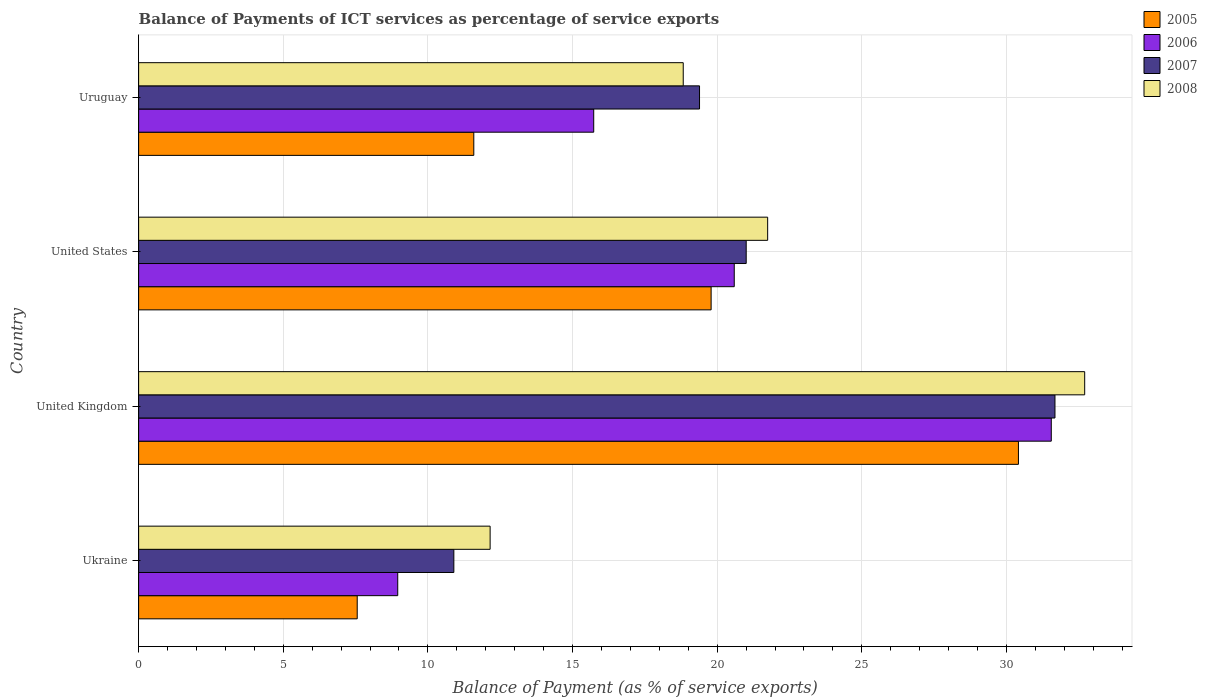How many different coloured bars are there?
Offer a terse response. 4. How many groups of bars are there?
Your answer should be very brief. 4. What is the label of the 2nd group of bars from the top?
Provide a succinct answer. United States. In how many cases, is the number of bars for a given country not equal to the number of legend labels?
Your answer should be very brief. 0. What is the balance of payments of ICT services in 2008 in Ukraine?
Provide a succinct answer. 12.15. Across all countries, what is the maximum balance of payments of ICT services in 2006?
Ensure brevity in your answer.  31.55. Across all countries, what is the minimum balance of payments of ICT services in 2005?
Your answer should be very brief. 7.56. In which country was the balance of payments of ICT services in 2006 minimum?
Keep it short and to the point. Ukraine. What is the total balance of payments of ICT services in 2008 in the graph?
Your answer should be very brief. 85.42. What is the difference between the balance of payments of ICT services in 2006 in United States and that in Uruguay?
Give a very brief answer. 4.86. What is the difference between the balance of payments of ICT services in 2005 in Ukraine and the balance of payments of ICT services in 2008 in Uruguay?
Give a very brief answer. -11.27. What is the average balance of payments of ICT services in 2005 per country?
Keep it short and to the point. 17.34. What is the difference between the balance of payments of ICT services in 2008 and balance of payments of ICT services in 2005 in United Kingdom?
Provide a succinct answer. 2.29. In how many countries, is the balance of payments of ICT services in 2005 greater than 5 %?
Give a very brief answer. 4. What is the ratio of the balance of payments of ICT services in 2006 in Ukraine to that in Uruguay?
Offer a very short reply. 0.57. Is the difference between the balance of payments of ICT services in 2008 in United Kingdom and Uruguay greater than the difference between the balance of payments of ICT services in 2005 in United Kingdom and Uruguay?
Give a very brief answer. No. What is the difference between the highest and the second highest balance of payments of ICT services in 2005?
Provide a succinct answer. 10.62. What is the difference between the highest and the lowest balance of payments of ICT services in 2006?
Ensure brevity in your answer.  22.59. Is the sum of the balance of payments of ICT services in 2008 in United Kingdom and United States greater than the maximum balance of payments of ICT services in 2006 across all countries?
Offer a terse response. Yes. What does the 1st bar from the top in Ukraine represents?
Offer a terse response. 2008. Is it the case that in every country, the sum of the balance of payments of ICT services in 2006 and balance of payments of ICT services in 2005 is greater than the balance of payments of ICT services in 2007?
Offer a very short reply. Yes. Are all the bars in the graph horizontal?
Provide a short and direct response. Yes. How many countries are there in the graph?
Ensure brevity in your answer.  4. Does the graph contain any zero values?
Offer a terse response. No. How many legend labels are there?
Offer a very short reply. 4. What is the title of the graph?
Make the answer very short. Balance of Payments of ICT services as percentage of service exports. Does "2006" appear as one of the legend labels in the graph?
Ensure brevity in your answer.  Yes. What is the label or title of the X-axis?
Your answer should be compact. Balance of Payment (as % of service exports). What is the Balance of Payment (as % of service exports) in 2005 in Ukraine?
Your answer should be very brief. 7.56. What is the Balance of Payment (as % of service exports) in 2006 in Ukraine?
Your answer should be compact. 8.96. What is the Balance of Payment (as % of service exports) of 2007 in Ukraine?
Keep it short and to the point. 10.9. What is the Balance of Payment (as % of service exports) in 2008 in Ukraine?
Your response must be concise. 12.15. What is the Balance of Payment (as % of service exports) in 2005 in United Kingdom?
Your answer should be compact. 30.41. What is the Balance of Payment (as % of service exports) in 2006 in United Kingdom?
Keep it short and to the point. 31.55. What is the Balance of Payment (as % of service exports) of 2007 in United Kingdom?
Your answer should be very brief. 31.68. What is the Balance of Payment (as % of service exports) in 2008 in United Kingdom?
Your response must be concise. 32.7. What is the Balance of Payment (as % of service exports) of 2005 in United States?
Your answer should be compact. 19.79. What is the Balance of Payment (as % of service exports) of 2006 in United States?
Give a very brief answer. 20.59. What is the Balance of Payment (as % of service exports) of 2007 in United States?
Your answer should be very brief. 21. What is the Balance of Payment (as % of service exports) in 2008 in United States?
Ensure brevity in your answer.  21.74. What is the Balance of Payment (as % of service exports) in 2005 in Uruguay?
Ensure brevity in your answer.  11.59. What is the Balance of Payment (as % of service exports) in 2006 in Uruguay?
Your answer should be very brief. 15.73. What is the Balance of Payment (as % of service exports) of 2007 in Uruguay?
Make the answer very short. 19.39. What is the Balance of Payment (as % of service exports) in 2008 in Uruguay?
Offer a terse response. 18.83. Across all countries, what is the maximum Balance of Payment (as % of service exports) of 2005?
Your answer should be very brief. 30.41. Across all countries, what is the maximum Balance of Payment (as % of service exports) in 2006?
Offer a terse response. 31.55. Across all countries, what is the maximum Balance of Payment (as % of service exports) in 2007?
Give a very brief answer. 31.68. Across all countries, what is the maximum Balance of Payment (as % of service exports) of 2008?
Offer a terse response. 32.7. Across all countries, what is the minimum Balance of Payment (as % of service exports) in 2005?
Keep it short and to the point. 7.56. Across all countries, what is the minimum Balance of Payment (as % of service exports) in 2006?
Provide a succinct answer. 8.96. Across all countries, what is the minimum Balance of Payment (as % of service exports) in 2007?
Provide a short and direct response. 10.9. Across all countries, what is the minimum Balance of Payment (as % of service exports) of 2008?
Make the answer very short. 12.15. What is the total Balance of Payment (as % of service exports) in 2005 in the graph?
Your answer should be compact. 69.34. What is the total Balance of Payment (as % of service exports) in 2006 in the graph?
Provide a succinct answer. 76.83. What is the total Balance of Payment (as % of service exports) of 2007 in the graph?
Provide a short and direct response. 82.96. What is the total Balance of Payment (as % of service exports) in 2008 in the graph?
Make the answer very short. 85.42. What is the difference between the Balance of Payment (as % of service exports) of 2005 in Ukraine and that in United Kingdom?
Ensure brevity in your answer.  -22.86. What is the difference between the Balance of Payment (as % of service exports) of 2006 in Ukraine and that in United Kingdom?
Keep it short and to the point. -22.59. What is the difference between the Balance of Payment (as % of service exports) of 2007 in Ukraine and that in United Kingdom?
Provide a short and direct response. -20.78. What is the difference between the Balance of Payment (as % of service exports) in 2008 in Ukraine and that in United Kingdom?
Offer a terse response. -20.55. What is the difference between the Balance of Payment (as % of service exports) in 2005 in Ukraine and that in United States?
Your answer should be very brief. -12.23. What is the difference between the Balance of Payment (as % of service exports) of 2006 in Ukraine and that in United States?
Ensure brevity in your answer.  -11.63. What is the difference between the Balance of Payment (as % of service exports) in 2007 in Ukraine and that in United States?
Your answer should be compact. -10.11. What is the difference between the Balance of Payment (as % of service exports) in 2008 in Ukraine and that in United States?
Your answer should be very brief. -9.59. What is the difference between the Balance of Payment (as % of service exports) of 2005 in Ukraine and that in Uruguay?
Your answer should be very brief. -4.03. What is the difference between the Balance of Payment (as % of service exports) in 2006 in Ukraine and that in Uruguay?
Offer a terse response. -6.77. What is the difference between the Balance of Payment (as % of service exports) in 2007 in Ukraine and that in Uruguay?
Offer a terse response. -8.49. What is the difference between the Balance of Payment (as % of service exports) in 2008 in Ukraine and that in Uruguay?
Your answer should be very brief. -6.68. What is the difference between the Balance of Payment (as % of service exports) of 2005 in United Kingdom and that in United States?
Your answer should be very brief. 10.62. What is the difference between the Balance of Payment (as % of service exports) of 2006 in United Kingdom and that in United States?
Offer a terse response. 10.96. What is the difference between the Balance of Payment (as % of service exports) of 2007 in United Kingdom and that in United States?
Provide a short and direct response. 10.67. What is the difference between the Balance of Payment (as % of service exports) in 2008 in United Kingdom and that in United States?
Your answer should be compact. 10.96. What is the difference between the Balance of Payment (as % of service exports) in 2005 in United Kingdom and that in Uruguay?
Provide a succinct answer. 18.83. What is the difference between the Balance of Payment (as % of service exports) in 2006 in United Kingdom and that in Uruguay?
Your answer should be compact. 15.82. What is the difference between the Balance of Payment (as % of service exports) of 2007 in United Kingdom and that in Uruguay?
Provide a short and direct response. 12.29. What is the difference between the Balance of Payment (as % of service exports) of 2008 in United Kingdom and that in Uruguay?
Your answer should be compact. 13.88. What is the difference between the Balance of Payment (as % of service exports) of 2005 in United States and that in Uruguay?
Your answer should be compact. 8.2. What is the difference between the Balance of Payment (as % of service exports) of 2006 in United States and that in Uruguay?
Make the answer very short. 4.86. What is the difference between the Balance of Payment (as % of service exports) in 2007 in United States and that in Uruguay?
Your answer should be very brief. 1.61. What is the difference between the Balance of Payment (as % of service exports) of 2008 in United States and that in Uruguay?
Provide a succinct answer. 2.92. What is the difference between the Balance of Payment (as % of service exports) in 2005 in Ukraine and the Balance of Payment (as % of service exports) in 2006 in United Kingdom?
Ensure brevity in your answer.  -23.99. What is the difference between the Balance of Payment (as % of service exports) in 2005 in Ukraine and the Balance of Payment (as % of service exports) in 2007 in United Kingdom?
Make the answer very short. -24.12. What is the difference between the Balance of Payment (as % of service exports) in 2005 in Ukraine and the Balance of Payment (as % of service exports) in 2008 in United Kingdom?
Ensure brevity in your answer.  -25.15. What is the difference between the Balance of Payment (as % of service exports) in 2006 in Ukraine and the Balance of Payment (as % of service exports) in 2007 in United Kingdom?
Provide a short and direct response. -22.72. What is the difference between the Balance of Payment (as % of service exports) in 2006 in Ukraine and the Balance of Payment (as % of service exports) in 2008 in United Kingdom?
Your answer should be compact. -23.75. What is the difference between the Balance of Payment (as % of service exports) of 2007 in Ukraine and the Balance of Payment (as % of service exports) of 2008 in United Kingdom?
Your answer should be very brief. -21.81. What is the difference between the Balance of Payment (as % of service exports) in 2005 in Ukraine and the Balance of Payment (as % of service exports) in 2006 in United States?
Keep it short and to the point. -13.03. What is the difference between the Balance of Payment (as % of service exports) in 2005 in Ukraine and the Balance of Payment (as % of service exports) in 2007 in United States?
Make the answer very short. -13.45. What is the difference between the Balance of Payment (as % of service exports) of 2005 in Ukraine and the Balance of Payment (as % of service exports) of 2008 in United States?
Offer a terse response. -14.19. What is the difference between the Balance of Payment (as % of service exports) of 2006 in Ukraine and the Balance of Payment (as % of service exports) of 2007 in United States?
Offer a terse response. -12.05. What is the difference between the Balance of Payment (as % of service exports) of 2006 in Ukraine and the Balance of Payment (as % of service exports) of 2008 in United States?
Your answer should be compact. -12.79. What is the difference between the Balance of Payment (as % of service exports) of 2007 in Ukraine and the Balance of Payment (as % of service exports) of 2008 in United States?
Offer a very short reply. -10.85. What is the difference between the Balance of Payment (as % of service exports) in 2005 in Ukraine and the Balance of Payment (as % of service exports) in 2006 in Uruguay?
Ensure brevity in your answer.  -8.18. What is the difference between the Balance of Payment (as % of service exports) in 2005 in Ukraine and the Balance of Payment (as % of service exports) in 2007 in Uruguay?
Make the answer very short. -11.83. What is the difference between the Balance of Payment (as % of service exports) in 2005 in Ukraine and the Balance of Payment (as % of service exports) in 2008 in Uruguay?
Your answer should be very brief. -11.27. What is the difference between the Balance of Payment (as % of service exports) of 2006 in Ukraine and the Balance of Payment (as % of service exports) of 2007 in Uruguay?
Offer a terse response. -10.43. What is the difference between the Balance of Payment (as % of service exports) of 2006 in Ukraine and the Balance of Payment (as % of service exports) of 2008 in Uruguay?
Your response must be concise. -9.87. What is the difference between the Balance of Payment (as % of service exports) of 2007 in Ukraine and the Balance of Payment (as % of service exports) of 2008 in Uruguay?
Offer a terse response. -7.93. What is the difference between the Balance of Payment (as % of service exports) in 2005 in United Kingdom and the Balance of Payment (as % of service exports) in 2006 in United States?
Ensure brevity in your answer.  9.82. What is the difference between the Balance of Payment (as % of service exports) in 2005 in United Kingdom and the Balance of Payment (as % of service exports) in 2007 in United States?
Make the answer very short. 9.41. What is the difference between the Balance of Payment (as % of service exports) in 2005 in United Kingdom and the Balance of Payment (as % of service exports) in 2008 in United States?
Ensure brevity in your answer.  8.67. What is the difference between the Balance of Payment (as % of service exports) in 2006 in United Kingdom and the Balance of Payment (as % of service exports) in 2007 in United States?
Keep it short and to the point. 10.55. What is the difference between the Balance of Payment (as % of service exports) in 2006 in United Kingdom and the Balance of Payment (as % of service exports) in 2008 in United States?
Your answer should be compact. 9.8. What is the difference between the Balance of Payment (as % of service exports) in 2007 in United Kingdom and the Balance of Payment (as % of service exports) in 2008 in United States?
Provide a short and direct response. 9.93. What is the difference between the Balance of Payment (as % of service exports) in 2005 in United Kingdom and the Balance of Payment (as % of service exports) in 2006 in Uruguay?
Offer a very short reply. 14.68. What is the difference between the Balance of Payment (as % of service exports) in 2005 in United Kingdom and the Balance of Payment (as % of service exports) in 2007 in Uruguay?
Keep it short and to the point. 11.02. What is the difference between the Balance of Payment (as % of service exports) of 2005 in United Kingdom and the Balance of Payment (as % of service exports) of 2008 in Uruguay?
Ensure brevity in your answer.  11.59. What is the difference between the Balance of Payment (as % of service exports) of 2006 in United Kingdom and the Balance of Payment (as % of service exports) of 2007 in Uruguay?
Ensure brevity in your answer.  12.16. What is the difference between the Balance of Payment (as % of service exports) in 2006 in United Kingdom and the Balance of Payment (as % of service exports) in 2008 in Uruguay?
Offer a terse response. 12.72. What is the difference between the Balance of Payment (as % of service exports) of 2007 in United Kingdom and the Balance of Payment (as % of service exports) of 2008 in Uruguay?
Offer a terse response. 12.85. What is the difference between the Balance of Payment (as % of service exports) of 2005 in United States and the Balance of Payment (as % of service exports) of 2006 in Uruguay?
Your answer should be very brief. 4.06. What is the difference between the Balance of Payment (as % of service exports) in 2005 in United States and the Balance of Payment (as % of service exports) in 2007 in Uruguay?
Ensure brevity in your answer.  0.4. What is the difference between the Balance of Payment (as % of service exports) in 2005 in United States and the Balance of Payment (as % of service exports) in 2008 in Uruguay?
Offer a terse response. 0.96. What is the difference between the Balance of Payment (as % of service exports) in 2006 in United States and the Balance of Payment (as % of service exports) in 2007 in Uruguay?
Your response must be concise. 1.2. What is the difference between the Balance of Payment (as % of service exports) in 2006 in United States and the Balance of Payment (as % of service exports) in 2008 in Uruguay?
Your answer should be compact. 1.76. What is the difference between the Balance of Payment (as % of service exports) in 2007 in United States and the Balance of Payment (as % of service exports) in 2008 in Uruguay?
Your answer should be very brief. 2.18. What is the average Balance of Payment (as % of service exports) of 2005 per country?
Provide a short and direct response. 17.34. What is the average Balance of Payment (as % of service exports) in 2006 per country?
Keep it short and to the point. 19.21. What is the average Balance of Payment (as % of service exports) in 2007 per country?
Offer a terse response. 20.74. What is the average Balance of Payment (as % of service exports) of 2008 per country?
Keep it short and to the point. 21.36. What is the difference between the Balance of Payment (as % of service exports) in 2005 and Balance of Payment (as % of service exports) in 2006 in Ukraine?
Your response must be concise. -1.4. What is the difference between the Balance of Payment (as % of service exports) in 2005 and Balance of Payment (as % of service exports) in 2007 in Ukraine?
Make the answer very short. -3.34. What is the difference between the Balance of Payment (as % of service exports) of 2005 and Balance of Payment (as % of service exports) of 2008 in Ukraine?
Make the answer very short. -4.59. What is the difference between the Balance of Payment (as % of service exports) in 2006 and Balance of Payment (as % of service exports) in 2007 in Ukraine?
Ensure brevity in your answer.  -1.94. What is the difference between the Balance of Payment (as % of service exports) in 2006 and Balance of Payment (as % of service exports) in 2008 in Ukraine?
Your response must be concise. -3.19. What is the difference between the Balance of Payment (as % of service exports) in 2007 and Balance of Payment (as % of service exports) in 2008 in Ukraine?
Provide a short and direct response. -1.25. What is the difference between the Balance of Payment (as % of service exports) of 2005 and Balance of Payment (as % of service exports) of 2006 in United Kingdom?
Your answer should be compact. -1.14. What is the difference between the Balance of Payment (as % of service exports) of 2005 and Balance of Payment (as % of service exports) of 2007 in United Kingdom?
Your answer should be very brief. -1.26. What is the difference between the Balance of Payment (as % of service exports) in 2005 and Balance of Payment (as % of service exports) in 2008 in United Kingdom?
Keep it short and to the point. -2.29. What is the difference between the Balance of Payment (as % of service exports) of 2006 and Balance of Payment (as % of service exports) of 2007 in United Kingdom?
Offer a very short reply. -0.13. What is the difference between the Balance of Payment (as % of service exports) of 2006 and Balance of Payment (as % of service exports) of 2008 in United Kingdom?
Offer a terse response. -1.16. What is the difference between the Balance of Payment (as % of service exports) of 2007 and Balance of Payment (as % of service exports) of 2008 in United Kingdom?
Keep it short and to the point. -1.03. What is the difference between the Balance of Payment (as % of service exports) in 2005 and Balance of Payment (as % of service exports) in 2006 in United States?
Offer a terse response. -0.8. What is the difference between the Balance of Payment (as % of service exports) in 2005 and Balance of Payment (as % of service exports) in 2007 in United States?
Keep it short and to the point. -1.21. What is the difference between the Balance of Payment (as % of service exports) in 2005 and Balance of Payment (as % of service exports) in 2008 in United States?
Your answer should be compact. -1.95. What is the difference between the Balance of Payment (as % of service exports) of 2006 and Balance of Payment (as % of service exports) of 2007 in United States?
Ensure brevity in your answer.  -0.41. What is the difference between the Balance of Payment (as % of service exports) in 2006 and Balance of Payment (as % of service exports) in 2008 in United States?
Your answer should be compact. -1.15. What is the difference between the Balance of Payment (as % of service exports) in 2007 and Balance of Payment (as % of service exports) in 2008 in United States?
Make the answer very short. -0.74. What is the difference between the Balance of Payment (as % of service exports) in 2005 and Balance of Payment (as % of service exports) in 2006 in Uruguay?
Provide a succinct answer. -4.15. What is the difference between the Balance of Payment (as % of service exports) in 2005 and Balance of Payment (as % of service exports) in 2007 in Uruguay?
Provide a succinct answer. -7.8. What is the difference between the Balance of Payment (as % of service exports) of 2005 and Balance of Payment (as % of service exports) of 2008 in Uruguay?
Your response must be concise. -7.24. What is the difference between the Balance of Payment (as % of service exports) in 2006 and Balance of Payment (as % of service exports) in 2007 in Uruguay?
Offer a very short reply. -3.66. What is the difference between the Balance of Payment (as % of service exports) in 2006 and Balance of Payment (as % of service exports) in 2008 in Uruguay?
Offer a terse response. -3.09. What is the difference between the Balance of Payment (as % of service exports) in 2007 and Balance of Payment (as % of service exports) in 2008 in Uruguay?
Your answer should be very brief. 0.56. What is the ratio of the Balance of Payment (as % of service exports) in 2005 in Ukraine to that in United Kingdom?
Provide a succinct answer. 0.25. What is the ratio of the Balance of Payment (as % of service exports) of 2006 in Ukraine to that in United Kingdom?
Keep it short and to the point. 0.28. What is the ratio of the Balance of Payment (as % of service exports) in 2007 in Ukraine to that in United Kingdom?
Provide a short and direct response. 0.34. What is the ratio of the Balance of Payment (as % of service exports) of 2008 in Ukraine to that in United Kingdom?
Your answer should be very brief. 0.37. What is the ratio of the Balance of Payment (as % of service exports) of 2005 in Ukraine to that in United States?
Your response must be concise. 0.38. What is the ratio of the Balance of Payment (as % of service exports) of 2006 in Ukraine to that in United States?
Provide a succinct answer. 0.43. What is the ratio of the Balance of Payment (as % of service exports) of 2007 in Ukraine to that in United States?
Ensure brevity in your answer.  0.52. What is the ratio of the Balance of Payment (as % of service exports) of 2008 in Ukraine to that in United States?
Provide a succinct answer. 0.56. What is the ratio of the Balance of Payment (as % of service exports) in 2005 in Ukraine to that in Uruguay?
Give a very brief answer. 0.65. What is the ratio of the Balance of Payment (as % of service exports) in 2006 in Ukraine to that in Uruguay?
Make the answer very short. 0.57. What is the ratio of the Balance of Payment (as % of service exports) of 2007 in Ukraine to that in Uruguay?
Your response must be concise. 0.56. What is the ratio of the Balance of Payment (as % of service exports) of 2008 in Ukraine to that in Uruguay?
Your answer should be very brief. 0.65. What is the ratio of the Balance of Payment (as % of service exports) in 2005 in United Kingdom to that in United States?
Offer a very short reply. 1.54. What is the ratio of the Balance of Payment (as % of service exports) in 2006 in United Kingdom to that in United States?
Make the answer very short. 1.53. What is the ratio of the Balance of Payment (as % of service exports) in 2007 in United Kingdom to that in United States?
Make the answer very short. 1.51. What is the ratio of the Balance of Payment (as % of service exports) of 2008 in United Kingdom to that in United States?
Offer a terse response. 1.5. What is the ratio of the Balance of Payment (as % of service exports) in 2005 in United Kingdom to that in Uruguay?
Provide a short and direct response. 2.62. What is the ratio of the Balance of Payment (as % of service exports) of 2006 in United Kingdom to that in Uruguay?
Keep it short and to the point. 2.01. What is the ratio of the Balance of Payment (as % of service exports) in 2007 in United Kingdom to that in Uruguay?
Offer a terse response. 1.63. What is the ratio of the Balance of Payment (as % of service exports) in 2008 in United Kingdom to that in Uruguay?
Ensure brevity in your answer.  1.74. What is the ratio of the Balance of Payment (as % of service exports) in 2005 in United States to that in Uruguay?
Provide a succinct answer. 1.71. What is the ratio of the Balance of Payment (as % of service exports) of 2006 in United States to that in Uruguay?
Your response must be concise. 1.31. What is the ratio of the Balance of Payment (as % of service exports) in 2007 in United States to that in Uruguay?
Make the answer very short. 1.08. What is the ratio of the Balance of Payment (as % of service exports) in 2008 in United States to that in Uruguay?
Your answer should be compact. 1.16. What is the difference between the highest and the second highest Balance of Payment (as % of service exports) of 2005?
Your response must be concise. 10.62. What is the difference between the highest and the second highest Balance of Payment (as % of service exports) of 2006?
Offer a very short reply. 10.96. What is the difference between the highest and the second highest Balance of Payment (as % of service exports) in 2007?
Your answer should be compact. 10.67. What is the difference between the highest and the second highest Balance of Payment (as % of service exports) of 2008?
Provide a short and direct response. 10.96. What is the difference between the highest and the lowest Balance of Payment (as % of service exports) in 2005?
Your response must be concise. 22.86. What is the difference between the highest and the lowest Balance of Payment (as % of service exports) of 2006?
Your response must be concise. 22.59. What is the difference between the highest and the lowest Balance of Payment (as % of service exports) of 2007?
Your answer should be very brief. 20.78. What is the difference between the highest and the lowest Balance of Payment (as % of service exports) of 2008?
Provide a short and direct response. 20.55. 